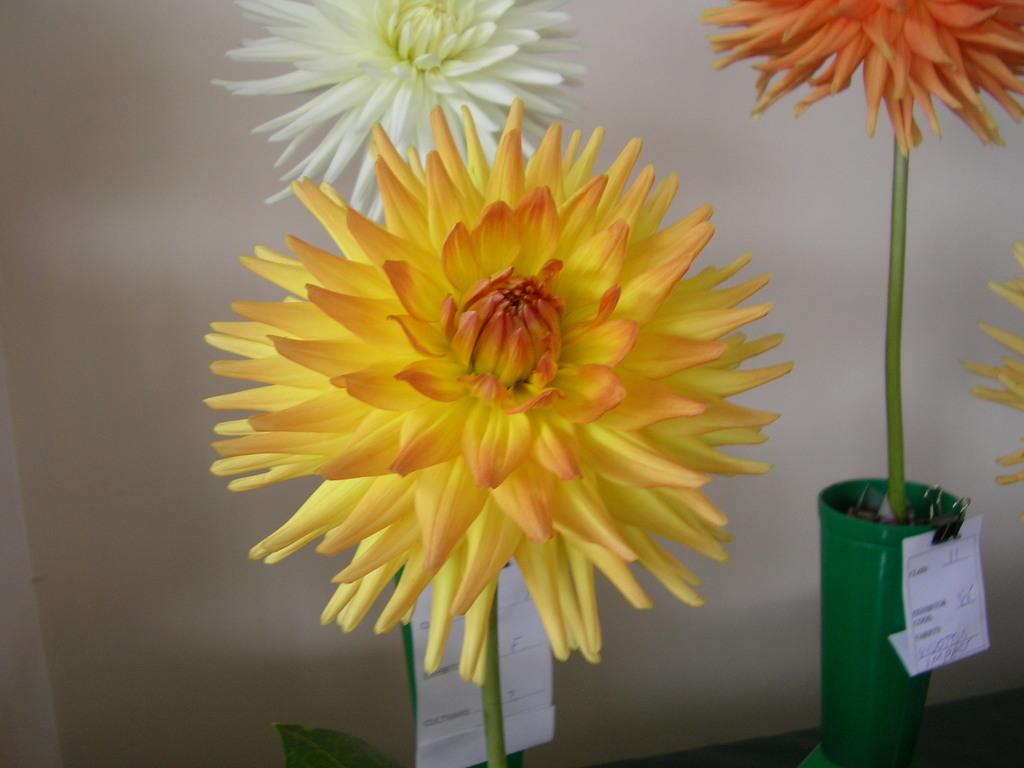What objects are present in the image that are related to plants? There are flower pots in the image. Where are the flower pots located? The flower pots are on a table. How can you identify the type of plant in each pot? The flower pots have labels. What type of motion can be seen in the heart of the flower pots? There is no heart present in the flower pots, and therefore no motion can be observed. 